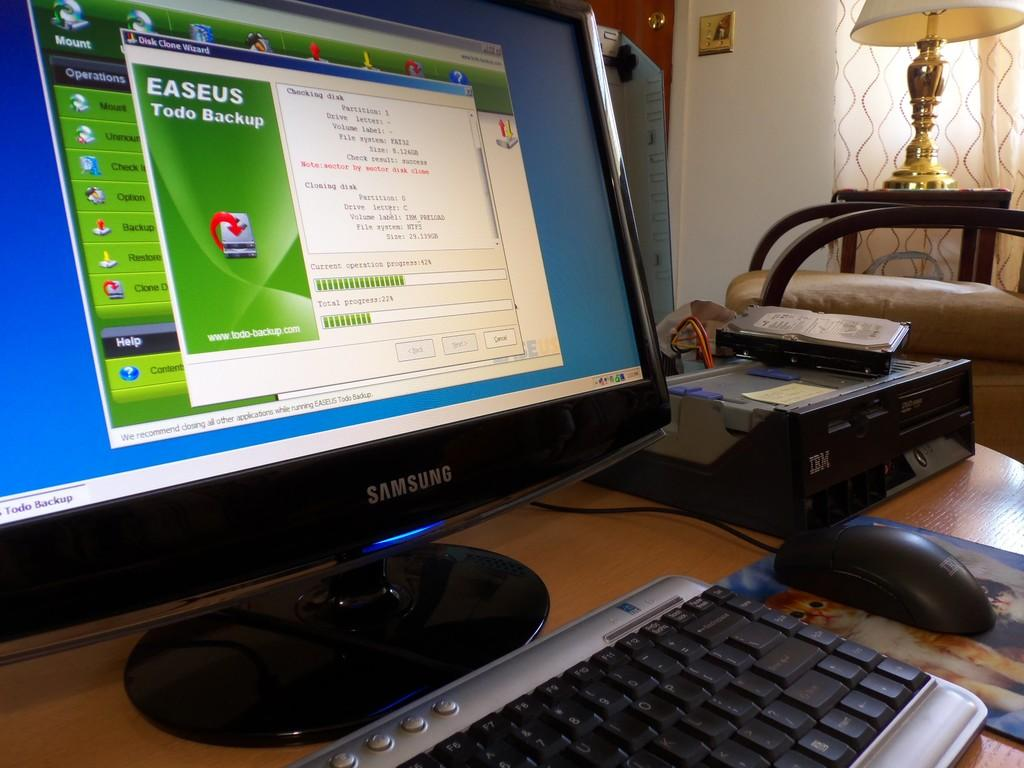<image>
Create a compact narrative representing the image presented. A Samsung computer with an open window from Disk Clone Wizard. 